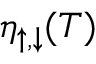<formula> <loc_0><loc_0><loc_500><loc_500>\eta _ { \uparrow , \downarrow } ( T )</formula> 